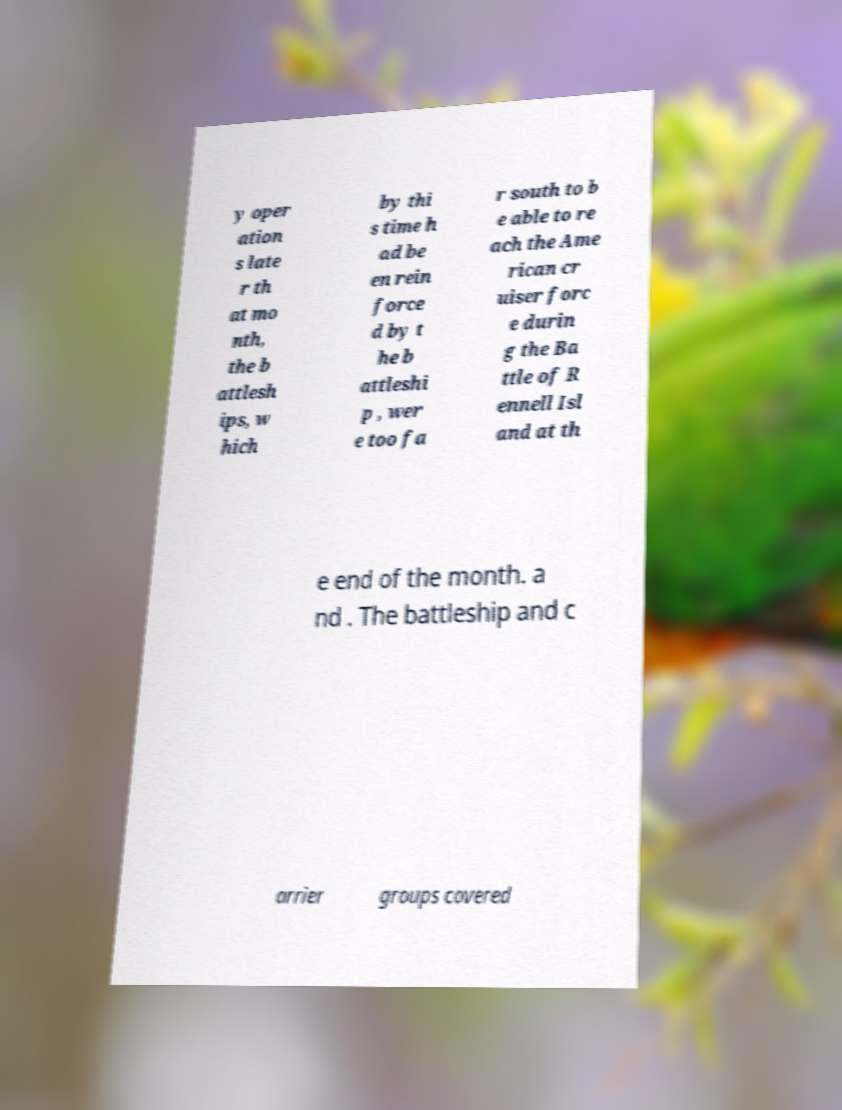Can you read and provide the text displayed in the image?This photo seems to have some interesting text. Can you extract and type it out for me? y oper ation s late r th at mo nth, the b attlesh ips, w hich by thi s time h ad be en rein force d by t he b attleshi p , wer e too fa r south to b e able to re ach the Ame rican cr uiser forc e durin g the Ba ttle of R ennell Isl and at th e end of the month. a nd . The battleship and c arrier groups covered 